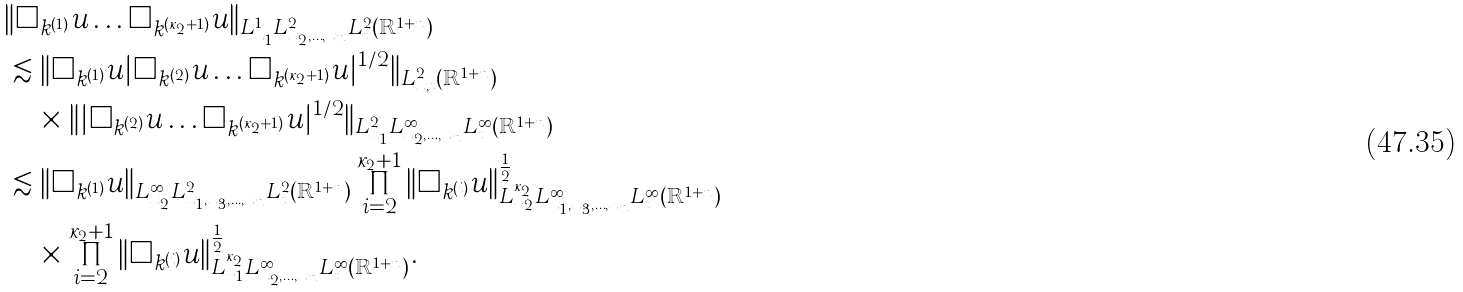Convert formula to latex. <formula><loc_0><loc_0><loc_500><loc_500>& \| \Box _ { k ^ { ( 1 ) } } u \dots \Box _ { k ^ { ( \kappa _ { 2 } + 1 ) } } u \| _ { L ^ { 1 } _ { x _ { 1 } } L ^ { 2 } _ { x _ { 2 } , \dots , x _ { n } } L ^ { 2 } _ { t } ( \mathbb { R } ^ { 1 + n } ) } \\ & \lesssim \| \Box _ { k ^ { ( 1 ) } } u | \Box _ { k ^ { ( 2 ) } } u \dots \Box _ { k ^ { ( \kappa _ { 2 } + 1 ) } } u | ^ { 1 / 2 } \| _ { L ^ { 2 } _ { x , t } ( \mathbb { R } ^ { 1 + n } ) } \\ & \quad \times \| | \Box _ { k ^ { ( 2 ) } } u \dots \Box _ { k ^ { ( \kappa _ { 2 } + 1 ) } } u | ^ { 1 / 2 } \| _ { L ^ { 2 } _ { x _ { 1 } } L ^ { \infty } _ { x _ { 2 } , \dots , x _ { n } } L ^ { \infty } _ { t } ( \mathbb { R } ^ { 1 + n } ) } \\ & \lesssim \| \Box _ { k ^ { ( 1 ) } } u \| _ { L ^ { \infty } _ { x _ { 2 } } L ^ { 2 } _ { x _ { 1 } , x _ { 3 } , \dots , x _ { n } } L ^ { 2 } _ { t } ( \mathbb { R } ^ { 1 + n } ) } \prod ^ { \kappa _ { 2 } + 1 } _ { i = 2 } \| \Box _ { k ^ { ( i ) } } u \| ^ { \frac { 1 } { 2 } } _ { L ^ { \kappa _ { 2 } } _ { x _ { 2 } } L ^ { \infty } _ { x _ { 1 } , x _ { 3 } , \dots , x _ { n } } L ^ { \infty } _ { t } ( \mathbb { R } ^ { 1 + n } ) } \\ & \quad \times \prod ^ { \kappa _ { 2 } + 1 } _ { i = 2 } \| \Box _ { k ^ { ( i ) } } u \| ^ { \frac { 1 } { 2 } } _ { L ^ { \kappa _ { 2 } } _ { x _ { 1 } } L ^ { \infty } _ { x _ { 2 } , \dots , x _ { n } } L ^ { \infty } _ { t } ( \mathbb { R } ^ { 1 + n } ) } .</formula> 